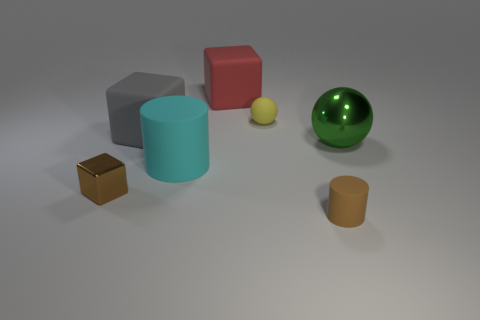Are the yellow thing and the block in front of the large gray thing made of the same material?
Your answer should be very brief. No. What is the big green sphere made of?
Your response must be concise. Metal. There is a tiny cylinder that is the same color as the tiny metal object; what is it made of?
Your answer should be compact. Rubber. What number of other things are made of the same material as the big red object?
Offer a very short reply. 4. The tiny object that is both left of the brown matte cylinder and in front of the small yellow sphere has what shape?
Ensure brevity in your answer.  Cube. There is a small cylinder that is made of the same material as the big cyan thing; what is its color?
Provide a short and direct response. Brown. Is the number of large matte cylinders to the right of the big red cube the same as the number of blue balls?
Offer a very short reply. Yes. What is the shape of the cyan matte thing that is the same size as the shiny ball?
Provide a succinct answer. Cylinder. What number of other objects are there of the same shape as the big cyan matte object?
Give a very brief answer. 1. Is the size of the yellow rubber thing the same as the metal thing on the left side of the large green sphere?
Make the answer very short. Yes. 